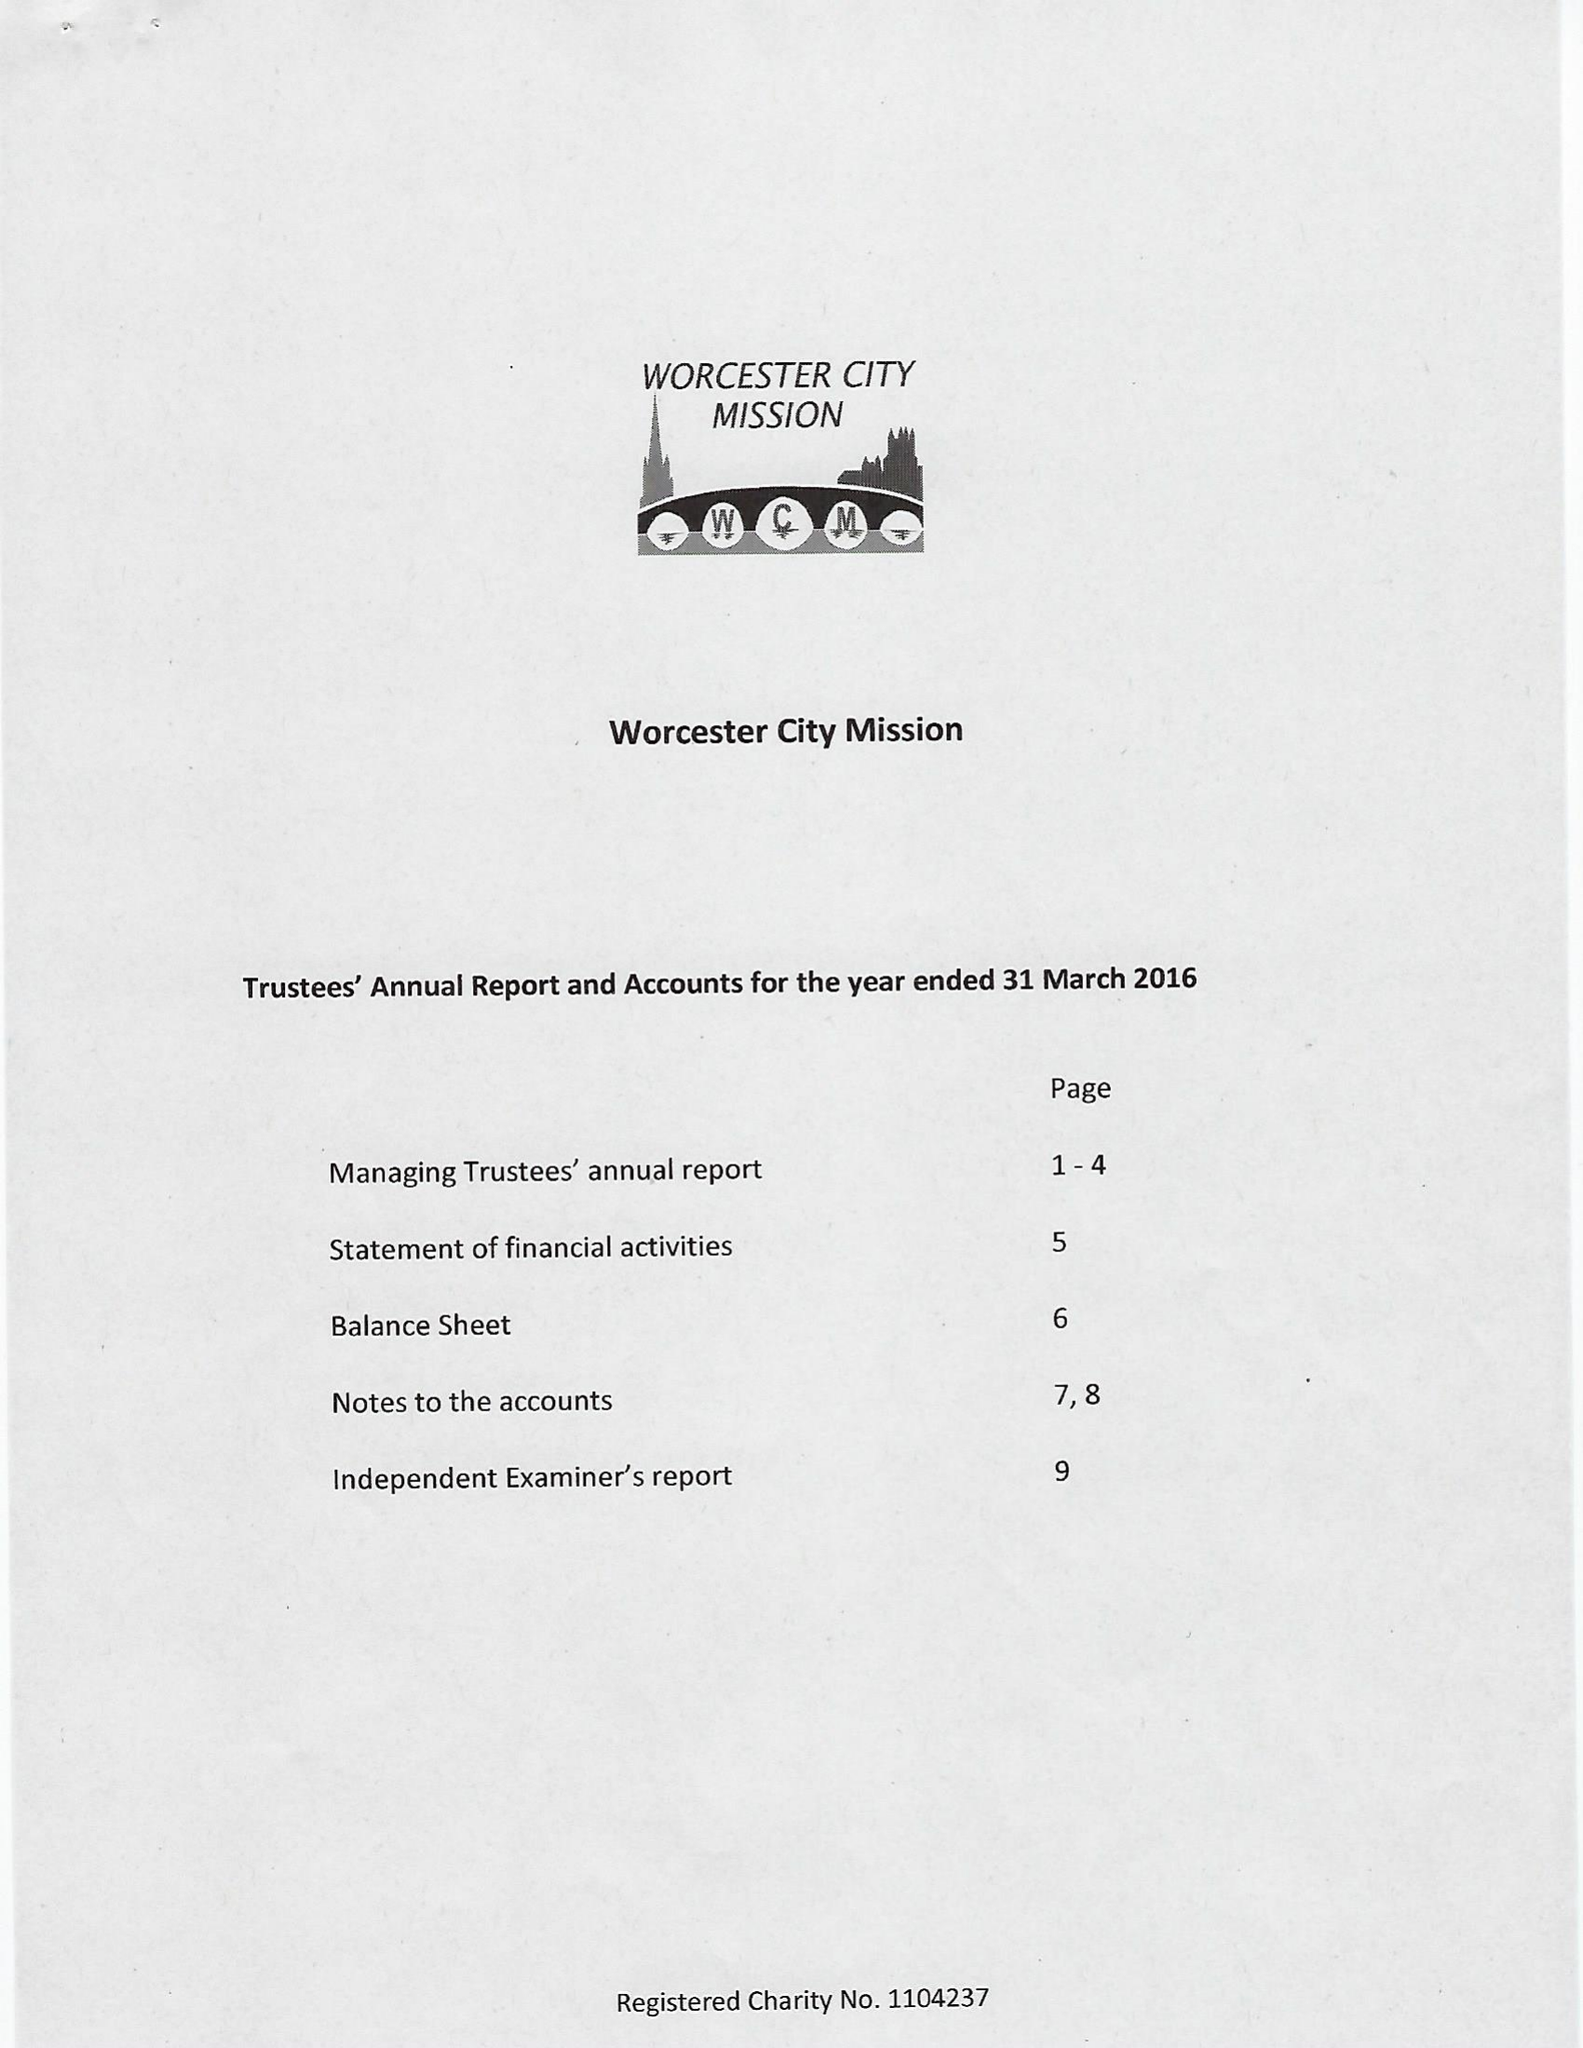What is the value for the report_date?
Answer the question using a single word or phrase. 2016-03-31 